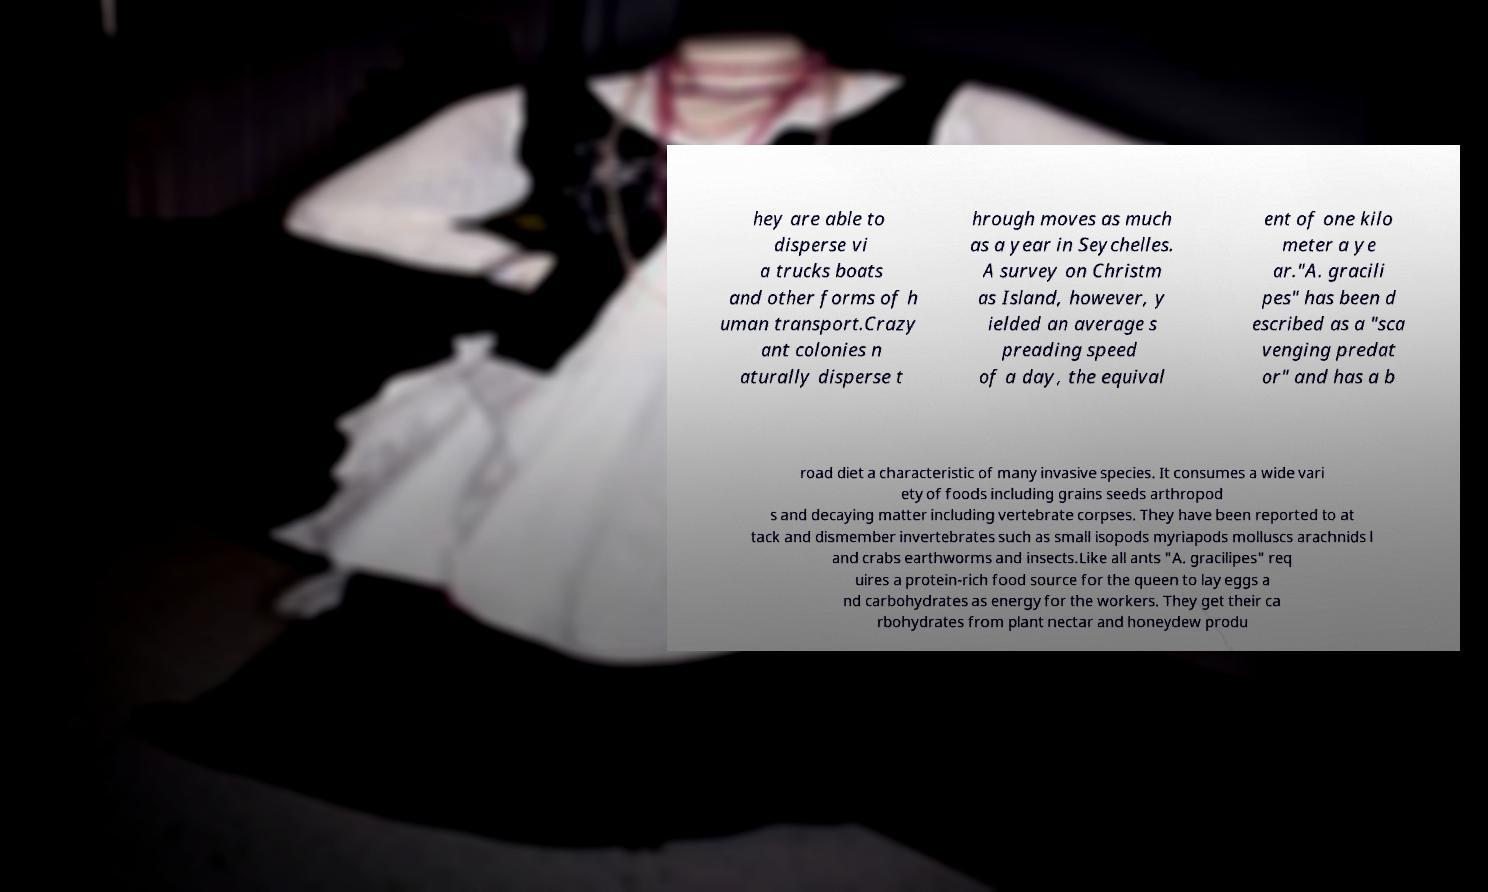Could you extract and type out the text from this image? hey are able to disperse vi a trucks boats and other forms of h uman transport.Crazy ant colonies n aturally disperse t hrough moves as much as a year in Seychelles. A survey on Christm as Island, however, y ielded an average s preading speed of a day, the equival ent of one kilo meter a ye ar."A. gracili pes" has been d escribed as a "sca venging predat or" and has a b road diet a characteristic of many invasive species. It consumes a wide vari ety of foods including grains seeds arthropod s and decaying matter including vertebrate corpses. They have been reported to at tack and dismember invertebrates such as small isopods myriapods molluscs arachnids l and crabs earthworms and insects.Like all ants "A. gracilipes" req uires a protein-rich food source for the queen to lay eggs a nd carbohydrates as energy for the workers. They get their ca rbohydrates from plant nectar and honeydew produ 